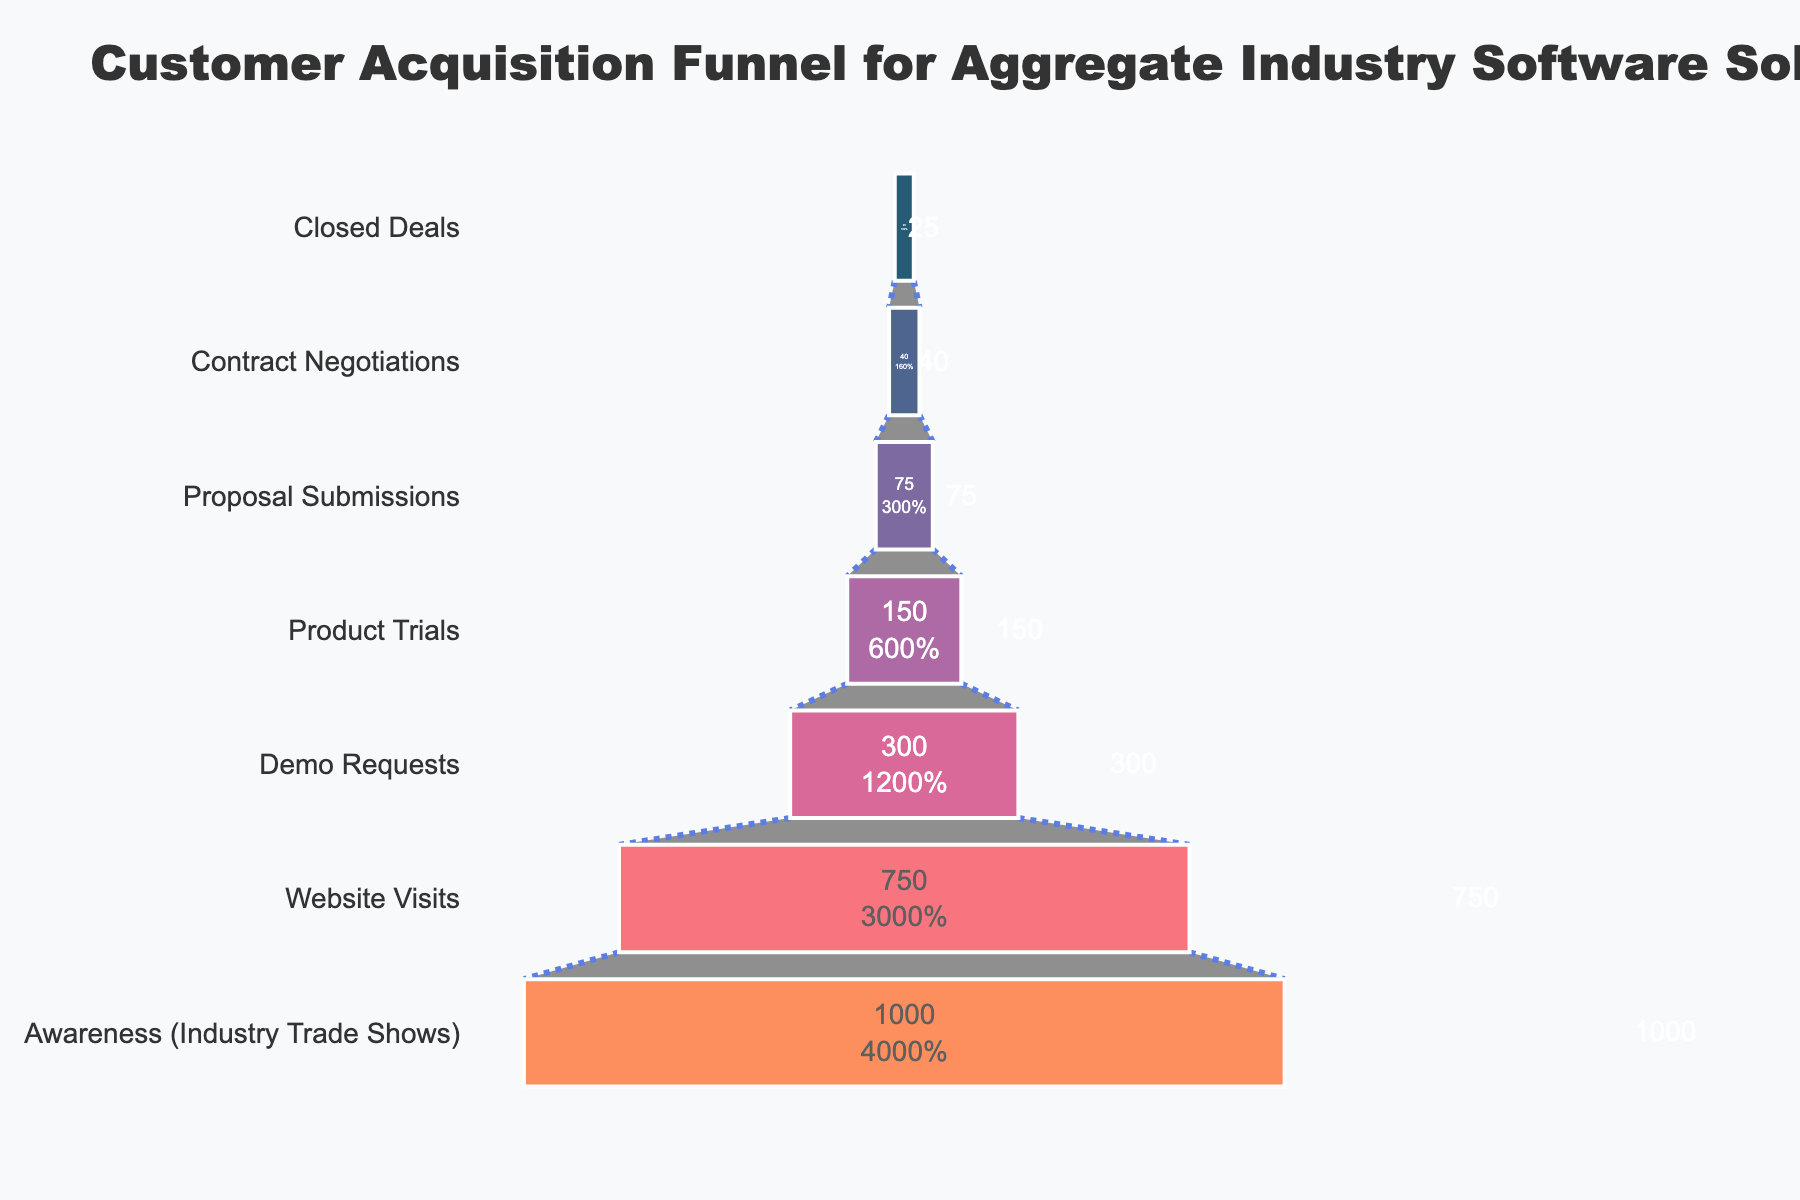What's the title of the figure? The title is displayed at the top of the chart and provides context for the visual data. In this case, it is "Customer Acquisition Funnel for Aggregate Industry Software Solutions"
Answer: Customer Acquisition Funnel for Aggregate Industry Software Solutions Which stage has the highest number of prospects? The stage with the highest number of prospects is positioned at the widest part of the funnel at the top, marked with the number 1000. This stage is labeled "Awareness (Industry Trade Shows)."
Answer: Awareness (Industry Trade Shows) What is the percentage of demo requests out of the initial number of prospects? To find the percentage, divide the number of demo requests by the initial number of prospects and multiply by 100. The initial number of prospects is 1000, and demo requests are 300. (300 / 1000) * 100 = 30%
Answer: 30% How many prospects went from product trials to proposal submissions? To find the difference between the number of prospects in product trials and those in proposal submissions, subtract the latter from the former. Product trials have 150 prospects, and proposal submissions have 75. 150 - 75 = 75
Answer: 75 By what percentage did the number of prospects decrease from contract negotiations to closed deals? To find the percentage decrease, subtract the number of closed deals from the number of contract negotiations, divide by the number of contract negotiations, and multiply by 100. (40 - 25) / 40 * 100%. (15 / 40) * 100 = 37.5%
Answer: 37.5% Which stage had the largest drop in the number of prospects? Identify the largest numerical difference between two consecutive stages. The largest drop is between "Website Visits" (750) and "Demo Requests" (300). 750 - 300 = 450
Answer: From Website Visits to Demo Requests How many stages are there in the funnel? Count the number of different stages listed on the left side of the funnel. There are seven stages: "Awareness (Industry Trade Shows)," "Website Visits," "Demo Requests," "Product Trials," "Proposal Submissions," "Contract Negotiations," and "Closed Deals."
Answer: 7 What is the average number of prospects across all stages? Add the number of prospects at each stage and divide by the total number of stages. (1000 + 750 + 300 + 150 + 75 + 40 + 25) / 7 = 2340 / 7 ≈ 334.29
Answer: ≈ 334.29 Which two consecutive stages have the smallest decrease in the number of prospects? Examine the numerical differences between consecutive stages and find the smallest decrease. The smallest decrease is from "Proposal Submissions" (75) to "Contract Negotiations" (40). 75 - 40 = 35
Answer: From Proposal Submissions to Contract Negotiations How many prospects didn't make it past the product trials stage? Subtract the number of prospects at the proposal submissions stage from the number at the product trials stage to find how many didn't progress. Product Trials has 150 prospects, and Proposal Submissions has 75. 150 - 75 = 75
Answer: 75 